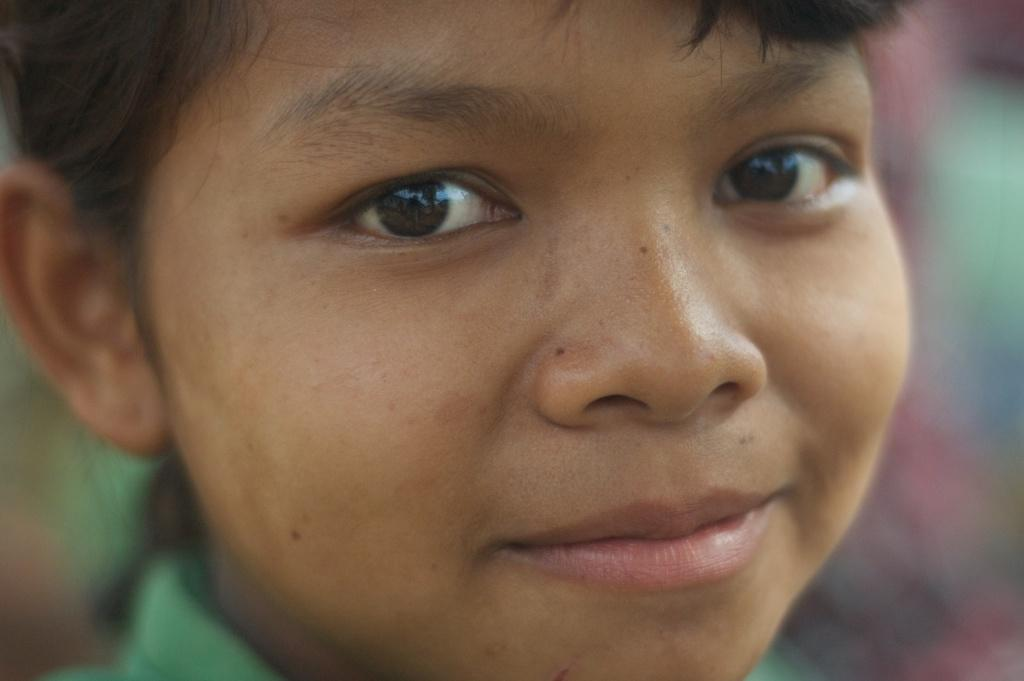What is the main subject of the image? There is a person in the image. What is the person wearing in the image? The person is wearing a green color shirt. Can you describe the background of the image? The background of the image is blurred. What type of animal can be seen kissing the person in the image? There is no animal present in the image, and therefore no such interaction can be observed. 